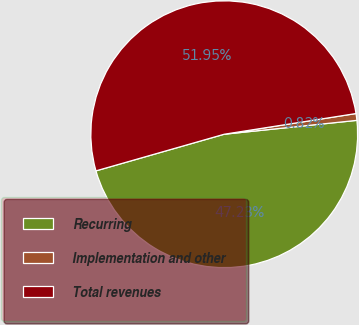Convert chart. <chart><loc_0><loc_0><loc_500><loc_500><pie_chart><fcel>Recurring<fcel>Implementation and other<fcel>Total revenues<nl><fcel>47.23%<fcel>0.82%<fcel>51.95%<nl></chart> 